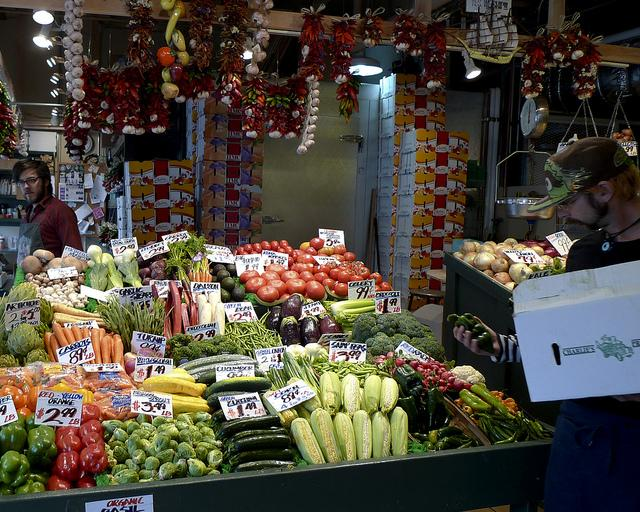Which vegetable is likely the most expensive item by piece or pound? brussel sprouts 